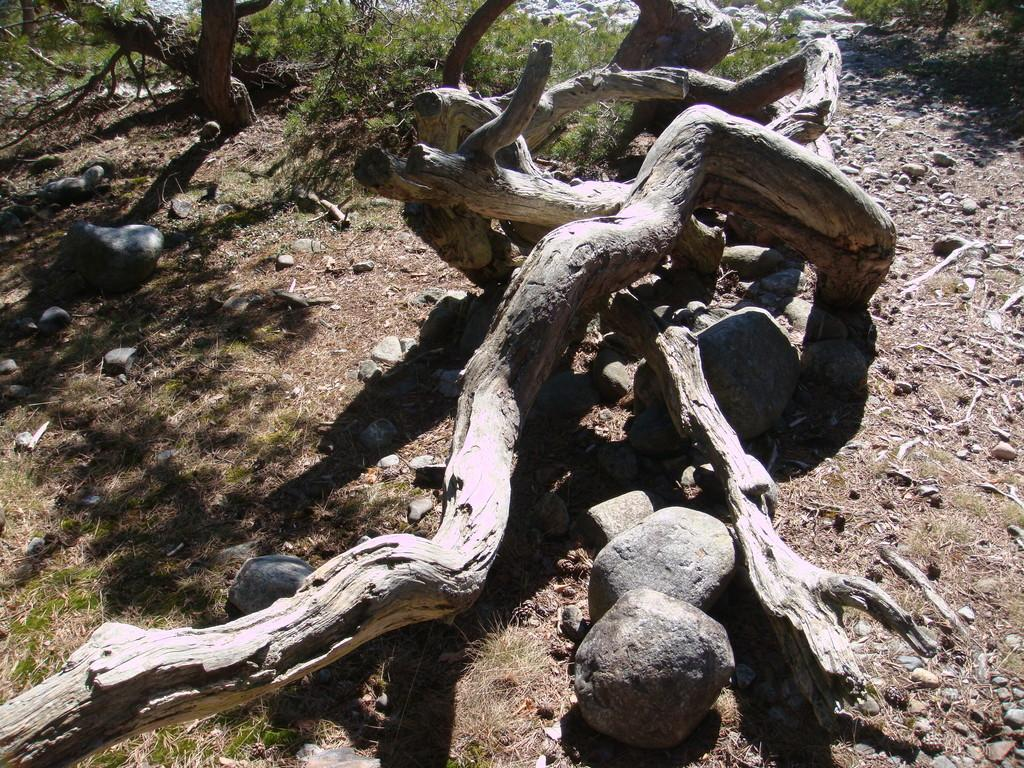What is the main object in the center of the image? There is a log in the center of the image. What other objects can be seen in the image? There are stones visible in the image. What type of vegetation is in the background of the image? There is grass in the background of the image. What else can be seen in the background of the image? There is a tree in the background of the image. What type of weather can be seen in the image? The image does not depict any weather conditions; it only shows a log, stones, grass, and a tree. Is there a sidewalk present in the image? There is no sidewalk visible in the image. 